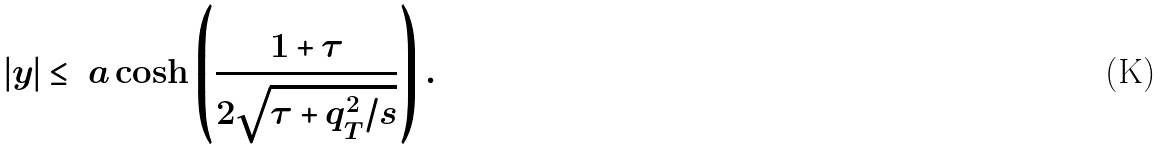Convert formula to latex. <formula><loc_0><loc_0><loc_500><loc_500>| y | \leq \ a \cosh \left ( \frac { 1 + \tau } { 2 \sqrt { \tau + q _ { T } ^ { 2 } / s } } \right ) .</formula> 